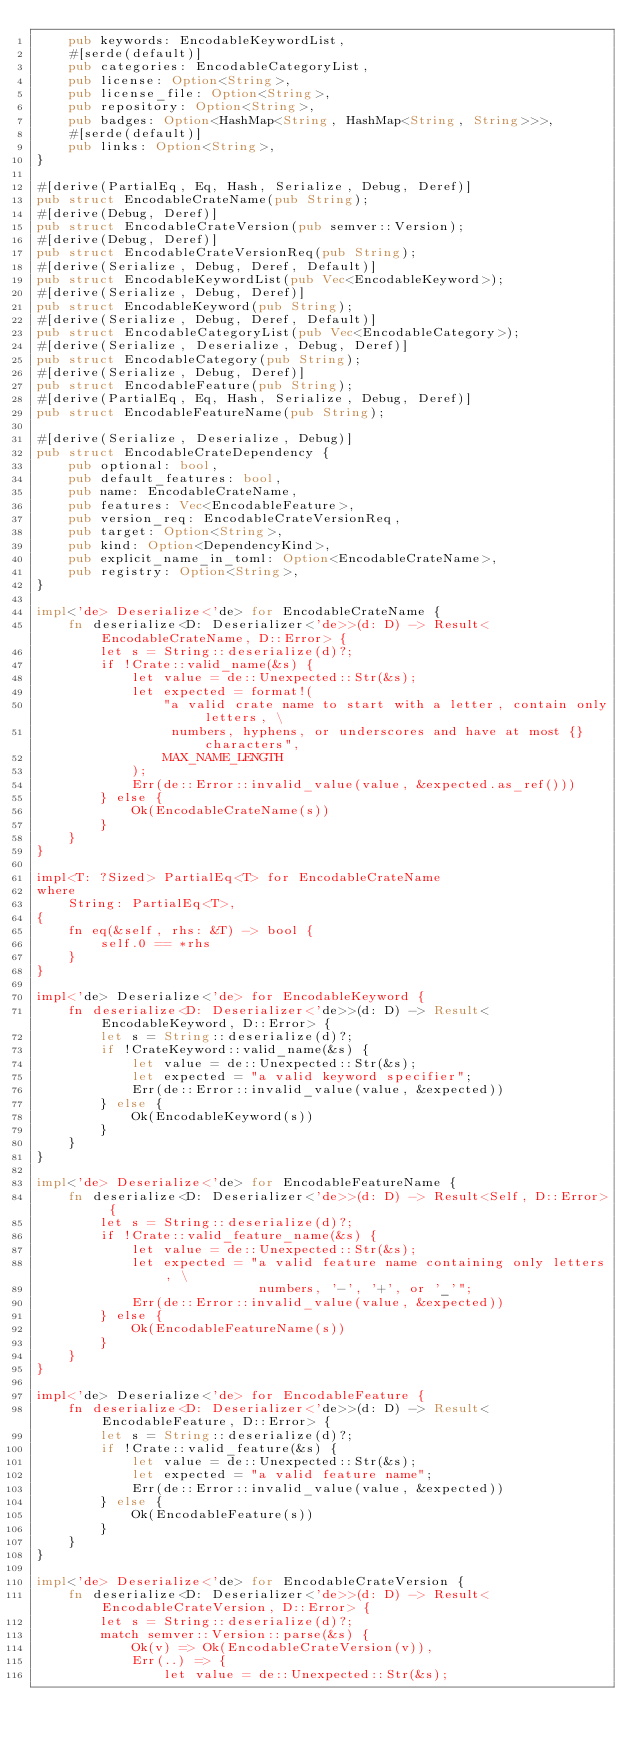<code> <loc_0><loc_0><loc_500><loc_500><_Rust_>    pub keywords: EncodableKeywordList,
    #[serde(default)]
    pub categories: EncodableCategoryList,
    pub license: Option<String>,
    pub license_file: Option<String>,
    pub repository: Option<String>,
    pub badges: Option<HashMap<String, HashMap<String, String>>>,
    #[serde(default)]
    pub links: Option<String>,
}

#[derive(PartialEq, Eq, Hash, Serialize, Debug, Deref)]
pub struct EncodableCrateName(pub String);
#[derive(Debug, Deref)]
pub struct EncodableCrateVersion(pub semver::Version);
#[derive(Debug, Deref)]
pub struct EncodableCrateVersionReq(pub String);
#[derive(Serialize, Debug, Deref, Default)]
pub struct EncodableKeywordList(pub Vec<EncodableKeyword>);
#[derive(Serialize, Debug, Deref)]
pub struct EncodableKeyword(pub String);
#[derive(Serialize, Debug, Deref, Default)]
pub struct EncodableCategoryList(pub Vec<EncodableCategory>);
#[derive(Serialize, Deserialize, Debug, Deref)]
pub struct EncodableCategory(pub String);
#[derive(Serialize, Debug, Deref)]
pub struct EncodableFeature(pub String);
#[derive(PartialEq, Eq, Hash, Serialize, Debug, Deref)]
pub struct EncodableFeatureName(pub String);

#[derive(Serialize, Deserialize, Debug)]
pub struct EncodableCrateDependency {
    pub optional: bool,
    pub default_features: bool,
    pub name: EncodableCrateName,
    pub features: Vec<EncodableFeature>,
    pub version_req: EncodableCrateVersionReq,
    pub target: Option<String>,
    pub kind: Option<DependencyKind>,
    pub explicit_name_in_toml: Option<EncodableCrateName>,
    pub registry: Option<String>,
}

impl<'de> Deserialize<'de> for EncodableCrateName {
    fn deserialize<D: Deserializer<'de>>(d: D) -> Result<EncodableCrateName, D::Error> {
        let s = String::deserialize(d)?;
        if !Crate::valid_name(&s) {
            let value = de::Unexpected::Str(&s);
            let expected = format!(
                "a valid crate name to start with a letter, contain only letters, \
                 numbers, hyphens, or underscores and have at most {} characters",
                MAX_NAME_LENGTH
            );
            Err(de::Error::invalid_value(value, &expected.as_ref()))
        } else {
            Ok(EncodableCrateName(s))
        }
    }
}

impl<T: ?Sized> PartialEq<T> for EncodableCrateName
where
    String: PartialEq<T>,
{
    fn eq(&self, rhs: &T) -> bool {
        self.0 == *rhs
    }
}

impl<'de> Deserialize<'de> for EncodableKeyword {
    fn deserialize<D: Deserializer<'de>>(d: D) -> Result<EncodableKeyword, D::Error> {
        let s = String::deserialize(d)?;
        if !CrateKeyword::valid_name(&s) {
            let value = de::Unexpected::Str(&s);
            let expected = "a valid keyword specifier";
            Err(de::Error::invalid_value(value, &expected))
        } else {
            Ok(EncodableKeyword(s))
        }
    }
}

impl<'de> Deserialize<'de> for EncodableFeatureName {
    fn deserialize<D: Deserializer<'de>>(d: D) -> Result<Self, D::Error> {
        let s = String::deserialize(d)?;
        if !Crate::valid_feature_name(&s) {
            let value = de::Unexpected::Str(&s);
            let expected = "a valid feature name containing only letters, \
                            numbers, '-', '+', or '_'";
            Err(de::Error::invalid_value(value, &expected))
        } else {
            Ok(EncodableFeatureName(s))
        }
    }
}

impl<'de> Deserialize<'de> for EncodableFeature {
    fn deserialize<D: Deserializer<'de>>(d: D) -> Result<EncodableFeature, D::Error> {
        let s = String::deserialize(d)?;
        if !Crate::valid_feature(&s) {
            let value = de::Unexpected::Str(&s);
            let expected = "a valid feature name";
            Err(de::Error::invalid_value(value, &expected))
        } else {
            Ok(EncodableFeature(s))
        }
    }
}

impl<'de> Deserialize<'de> for EncodableCrateVersion {
    fn deserialize<D: Deserializer<'de>>(d: D) -> Result<EncodableCrateVersion, D::Error> {
        let s = String::deserialize(d)?;
        match semver::Version::parse(&s) {
            Ok(v) => Ok(EncodableCrateVersion(v)),
            Err(..) => {
                let value = de::Unexpected::Str(&s);</code> 